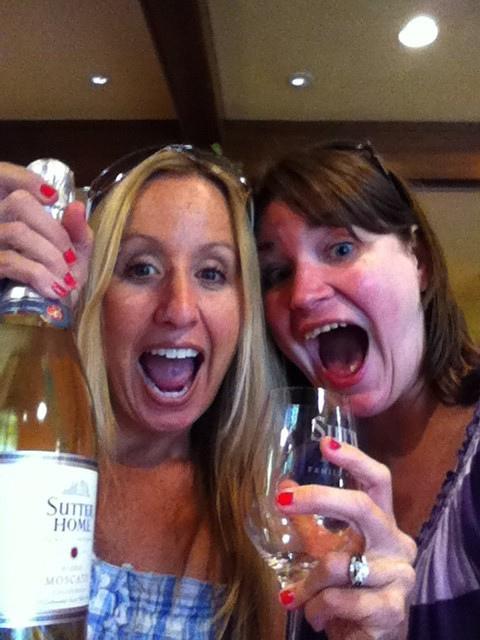What emotion are the woman exhibiting?
Answer the question by selecting the correct answer among the 4 following choices.
Options: Joyful, surprised, scared, fearful. Joyful. 